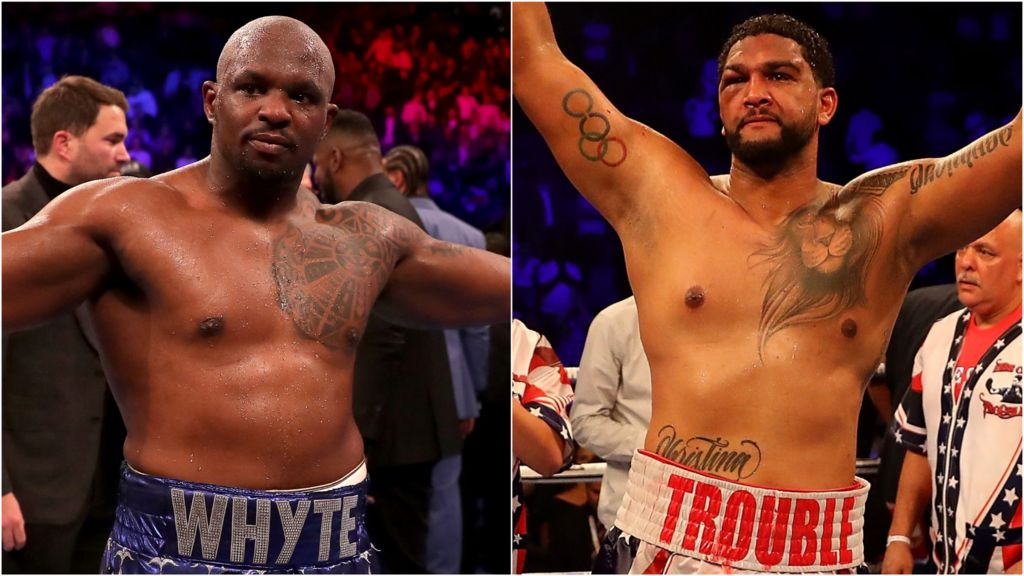If these boxers were to explain the significance of their tattoos in a documentary, what stories might they share? If these boxers were to share the stories behind their tattoos in a documentary, the narratives would likely be rich with personal history, cultural heritage, and their life's pivotal moments. The boxer on the left might share a story about the intricate patterns of his tattoos, which could symbolize his roots, the struggles he’s faced, and the personal vows he’s made. The boxer on the right with the Olympic rings might recount his journey to the Olympics, the years of toil and dedication it took to stand on that prestigious platform, and what the rings represent in terms of his commitment to excellence. The lion tattoo might open a dialogue about his fighting spirit, the battles he has fought both inside and outside the ring, and his aspirations to remain at the top of his game, embodying the lion's attributes of strength, pride, and dominance. 